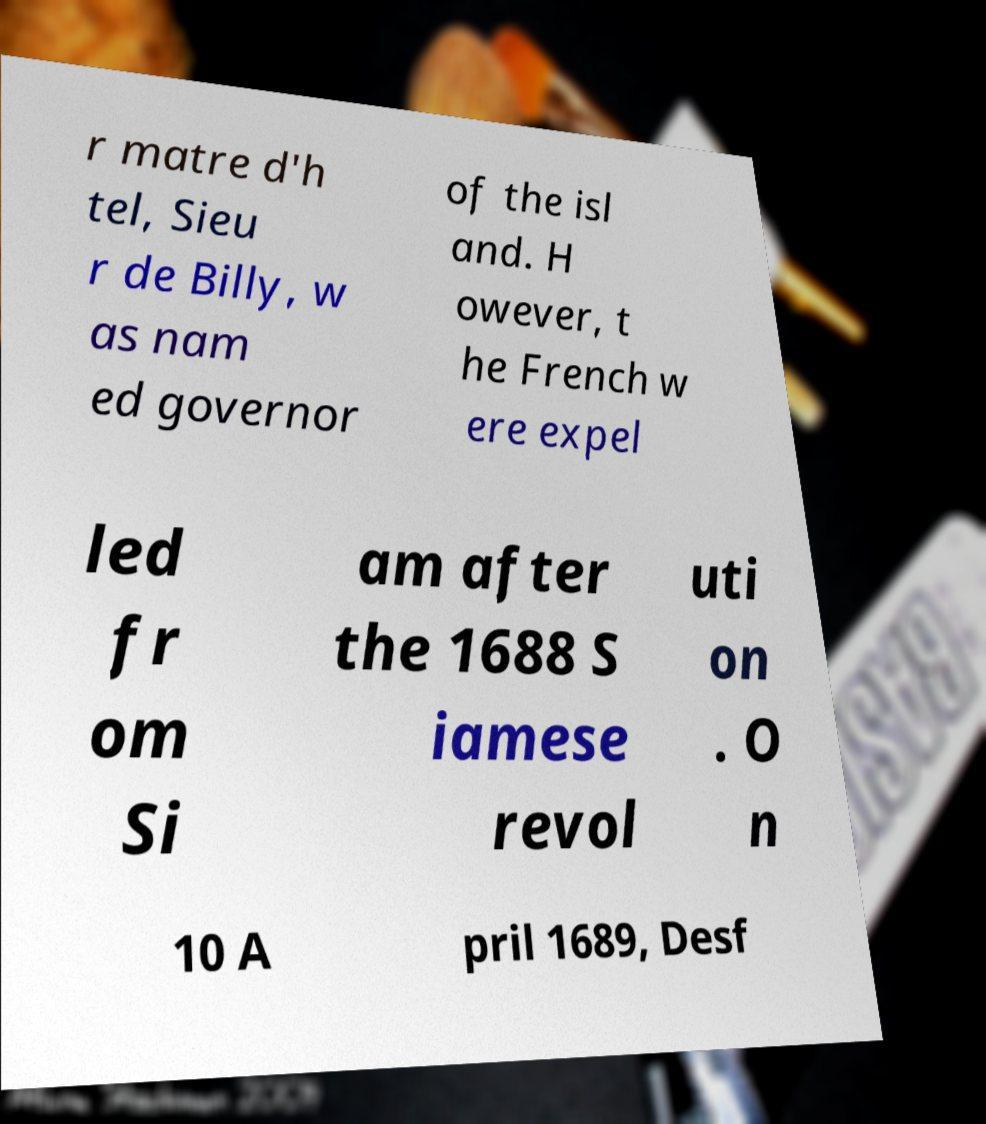There's text embedded in this image that I need extracted. Can you transcribe it verbatim? r matre d'h tel, Sieu r de Billy, w as nam ed governor of the isl and. H owever, t he French w ere expel led fr om Si am after the 1688 S iamese revol uti on . O n 10 A pril 1689, Desf 